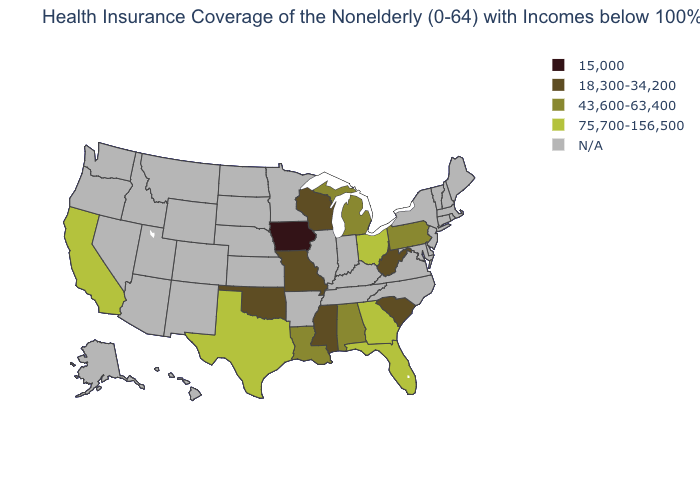Among the states that border Arizona , which have the highest value?
Concise answer only. California. Name the states that have a value in the range 18,300-34,200?
Give a very brief answer. Mississippi, Missouri, Oklahoma, South Carolina, West Virginia, Wisconsin. Does the first symbol in the legend represent the smallest category?
Concise answer only. Yes. What is the value of Ohio?
Keep it brief. 75,700-156,500. Does Missouri have the highest value in the USA?
Give a very brief answer. No. Which states have the lowest value in the USA?
Quick response, please. Iowa. What is the lowest value in the South?
Give a very brief answer. 18,300-34,200. What is the highest value in the USA?
Concise answer only. 75,700-156,500. What is the value of New Hampshire?
Quick response, please. N/A. Name the states that have a value in the range 75,700-156,500?
Answer briefly. California, Florida, Georgia, Ohio, Texas. What is the value of Nevada?
Answer briefly. N/A. What is the highest value in the USA?
Write a very short answer. 75,700-156,500. Among the states that border Texas , does Louisiana have the lowest value?
Be succinct. No. What is the value of Idaho?
Answer briefly. N/A. 